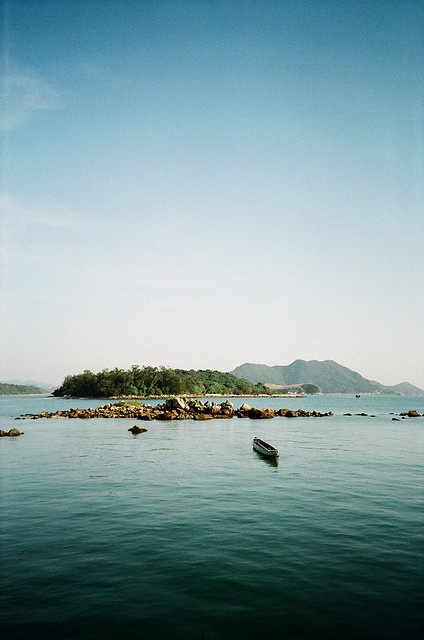Describe the objects in this image and their specific colors. I can see boat in blue, black, gray, teal, and darkgray tones and boat in blue, gray, black, and purple tones in this image. 